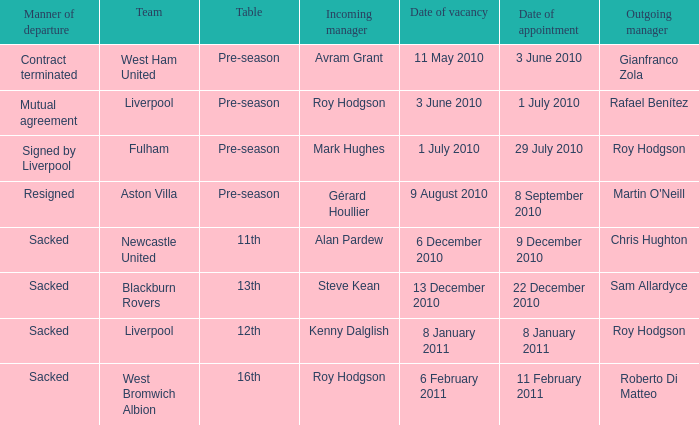What was the date of appointment for incoming manager Roy Hodgson and the team is Liverpool? 1 July 2010. 